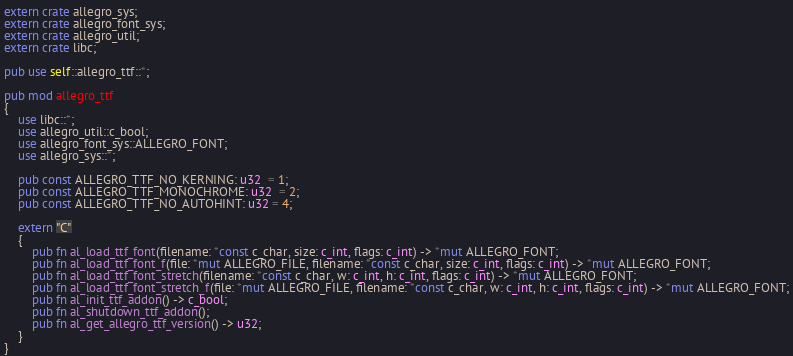Convert code to text. <code><loc_0><loc_0><loc_500><loc_500><_Rust_>
extern crate allegro_sys;
extern crate allegro_font_sys;
extern crate allegro_util;
extern crate libc;

pub use self::allegro_ttf::*;

pub mod allegro_ttf
{
	use libc::*;
	use allegro_util::c_bool;
	use allegro_font_sys::ALLEGRO_FONT;
	use allegro_sys::*;

	pub const ALLEGRO_TTF_NO_KERNING: u32  = 1;
	pub const ALLEGRO_TTF_MONOCHROME: u32  = 2;
	pub const ALLEGRO_TTF_NO_AUTOHINT: u32 = 4;

	extern "C"
	{
		pub fn al_load_ttf_font(filename: *const c_char, size: c_int, flags: c_int) -> *mut ALLEGRO_FONT;
		pub fn al_load_ttf_font_f(file: *mut ALLEGRO_FILE, filename: *const c_char, size: c_int, flags: c_int) -> *mut ALLEGRO_FONT;
		pub fn al_load_ttf_font_stretch(filename: *const c_char, w: c_int, h: c_int, flags: c_int) -> *mut ALLEGRO_FONT;
		pub fn al_load_ttf_font_stretch_f(file: *mut ALLEGRO_FILE, filename: *const c_char, w: c_int, h: c_int, flags: c_int) -> *mut ALLEGRO_FONT;
		pub fn al_init_ttf_addon() -> c_bool;
		pub fn al_shutdown_ttf_addon();
		pub fn al_get_allegro_ttf_version() -> u32;
	}
}
</code> 